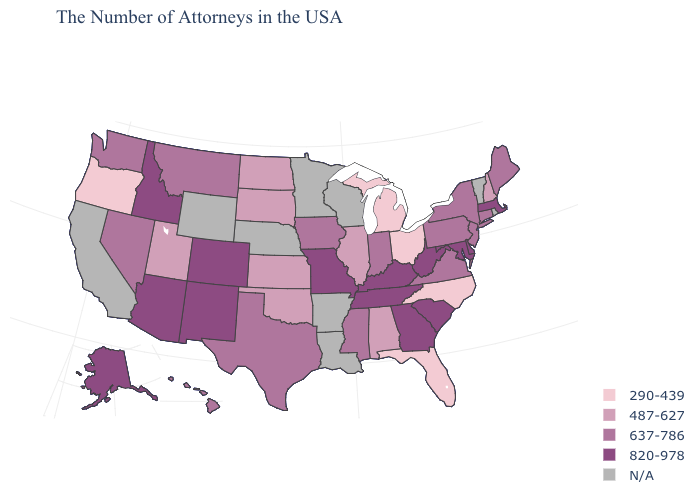Does Ohio have the lowest value in the USA?
Keep it brief. Yes. Does the map have missing data?
Keep it brief. Yes. What is the highest value in the USA?
Be succinct. 820-978. Among the states that border Illinois , does Missouri have the highest value?
Quick response, please. Yes. How many symbols are there in the legend?
Short answer required. 5. Does Texas have the lowest value in the USA?
Concise answer only. No. Does Missouri have the highest value in the MidWest?
Short answer required. Yes. Which states have the lowest value in the USA?
Write a very short answer. North Carolina, Ohio, Florida, Michigan, Oregon. Which states have the highest value in the USA?
Keep it brief. Massachusetts, Delaware, Maryland, South Carolina, West Virginia, Georgia, Kentucky, Tennessee, Missouri, Colorado, New Mexico, Arizona, Idaho, Alaska. Is the legend a continuous bar?
Write a very short answer. No. Name the states that have a value in the range 290-439?
Keep it brief. North Carolina, Ohio, Florida, Michigan, Oregon. Name the states that have a value in the range N/A?
Concise answer only. Rhode Island, Vermont, Wisconsin, Louisiana, Arkansas, Minnesota, Nebraska, Wyoming, California. 